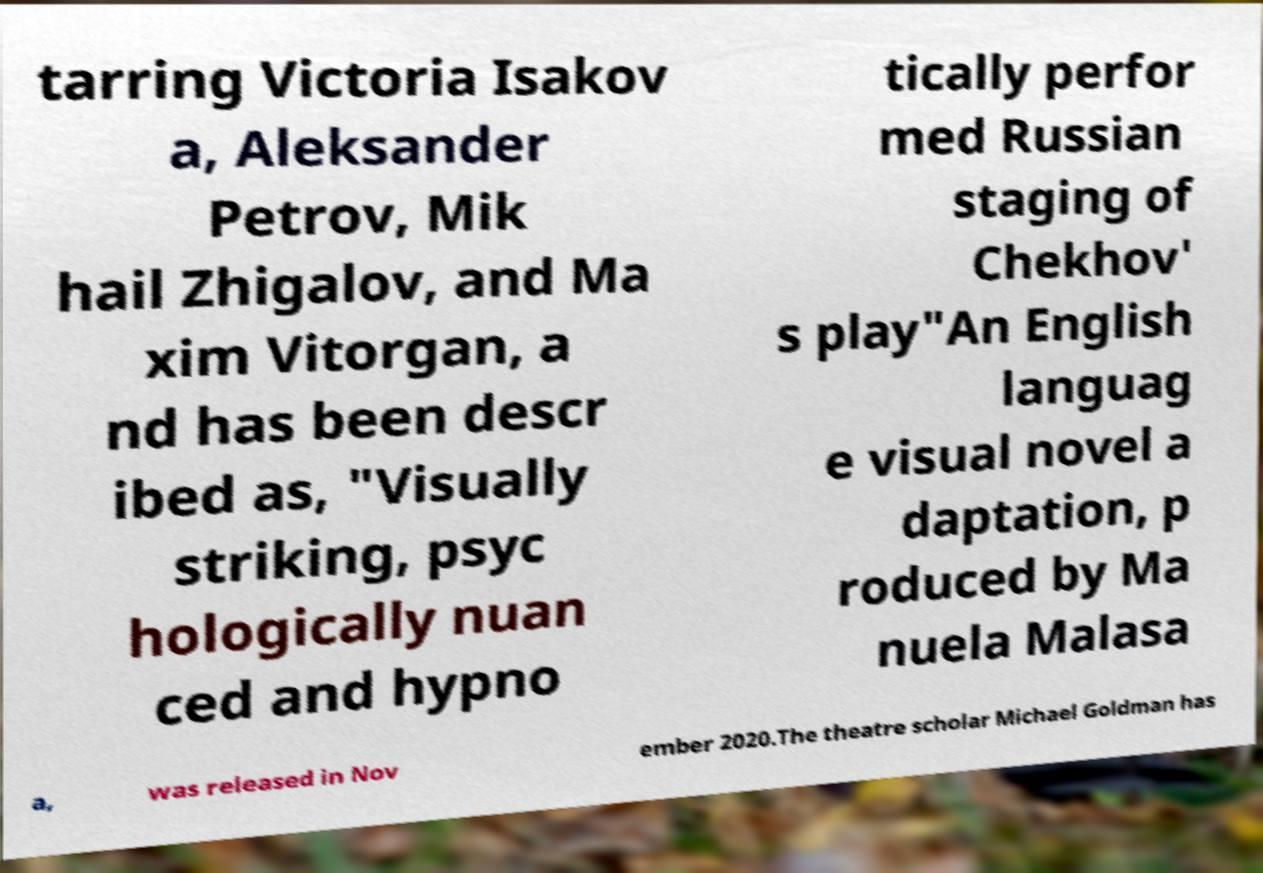I need the written content from this picture converted into text. Can you do that? tarring Victoria Isakov a, Aleksander Petrov, Mik hail Zhigalov, and Ma xim Vitorgan, a nd has been descr ibed as, "Visually striking, psyc hologically nuan ced and hypno tically perfor med Russian staging of Chekhov' s play"An English languag e visual novel a daptation, p roduced by Ma nuela Malasa a, was released in Nov ember 2020.The theatre scholar Michael Goldman has 